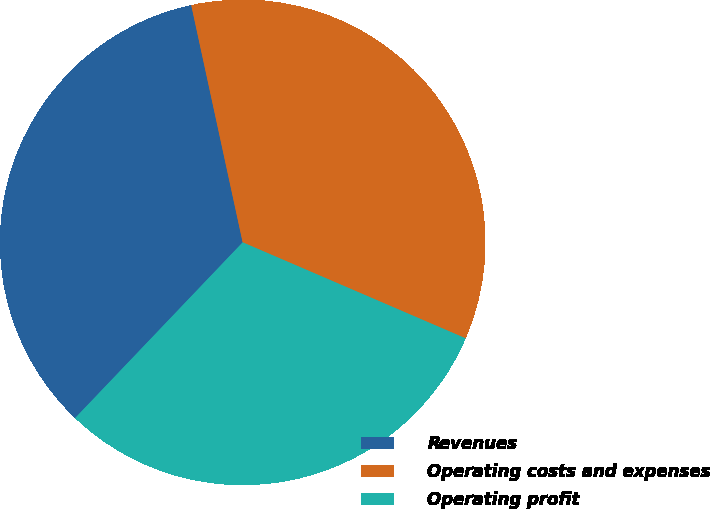<chart> <loc_0><loc_0><loc_500><loc_500><pie_chart><fcel>Revenues<fcel>Operating costs and expenses<fcel>Operating profit<nl><fcel>34.48%<fcel>34.87%<fcel>30.65%<nl></chart> 